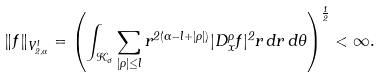Convert formula to latex. <formula><loc_0><loc_0><loc_500><loc_500>\| f \| _ { V ^ { l } _ { 2 , \alpha } } = \left ( \int _ { { \mathcal { K } } _ { \sigma } } { \sum _ { | \rho | \leq l } r ^ { 2 ( \alpha - l + | \rho | ) } | D ^ { \rho } _ { x } f | ^ { 2 } } r \, d r \, d \theta \right ) ^ { \frac { 1 } { 2 } } < \infty .</formula> 